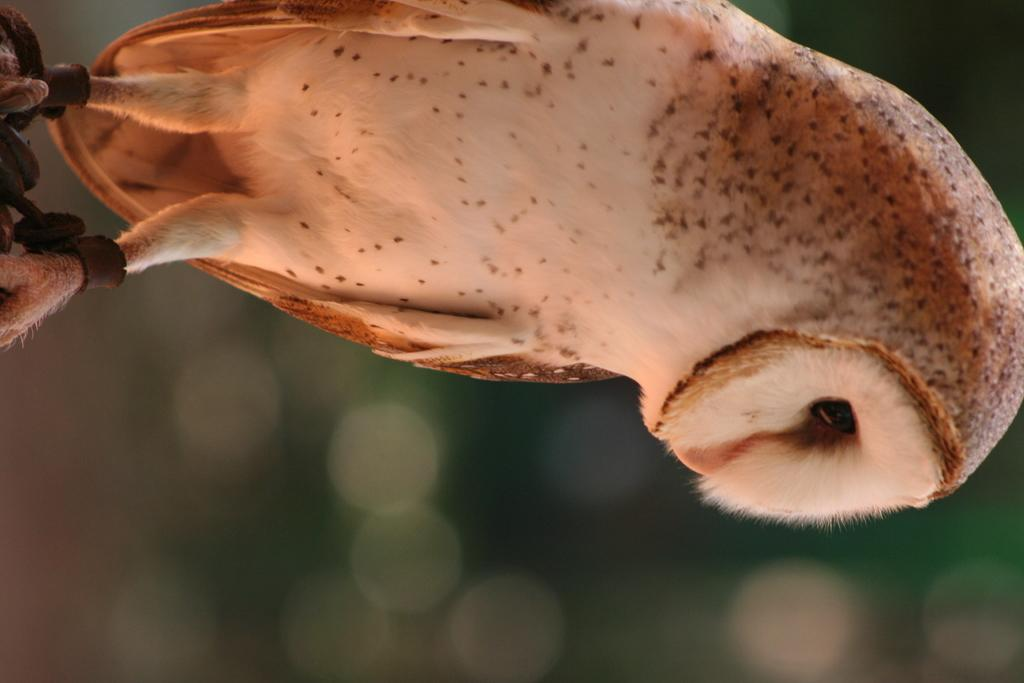In which direction is the image oriented? The image is in a rightward direction. What type of animal can be seen in the image? There is a bird in the image. Where is the bird located in the image? The bird is on the top of the image. What colors are the bird's feathers? The bird is brown and cream in color. What type of whip is the bird using to fly in the image? There is no whip present in the image, and the bird is not using any tool to fly. 